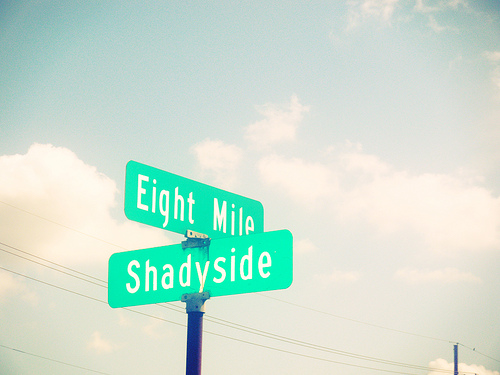What time of day does it appear to be based on the lighting in this photograph? Judging by the lighting and the clear blue sky with scattered clouds, it looks to be midday. The shadows are fairly short, suggesting that the sun is high in the sky, typical of the middle of the day. 